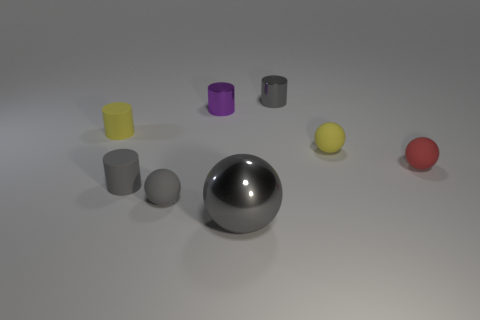How many gray cylinders must be subtracted to get 1 gray cylinders? 1 Subtract all purple cylinders. How many gray balls are left? 2 Subtract all yellow balls. How many balls are left? 3 Subtract all gray matte cylinders. How many cylinders are left? 3 Subtract 1 balls. How many balls are left? 3 Add 2 blue rubber cylinders. How many objects exist? 10 Subtract all blue spheres. Subtract all red blocks. How many spheres are left? 4 Add 5 small gray spheres. How many small gray spheres exist? 6 Subtract 0 green spheres. How many objects are left? 8 Subtract all matte cylinders. Subtract all big balls. How many objects are left? 5 